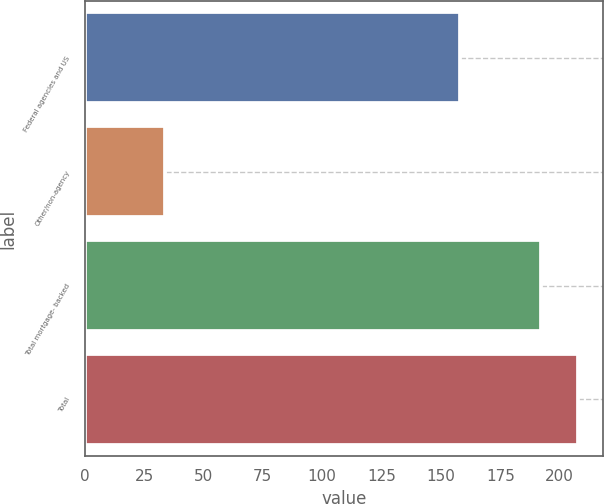<chart> <loc_0><loc_0><loc_500><loc_500><bar_chart><fcel>Federal agencies and US<fcel>Other/non-agency<fcel>Total mortgage- backed<fcel>Total<nl><fcel>158<fcel>34<fcel>192<fcel>207.9<nl></chart> 